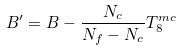Convert formula to latex. <formula><loc_0><loc_0><loc_500><loc_500>B ^ { \prime } = B - \frac { N _ { c } } { N _ { f } - N _ { c } } T _ { 8 } ^ { m c }</formula> 